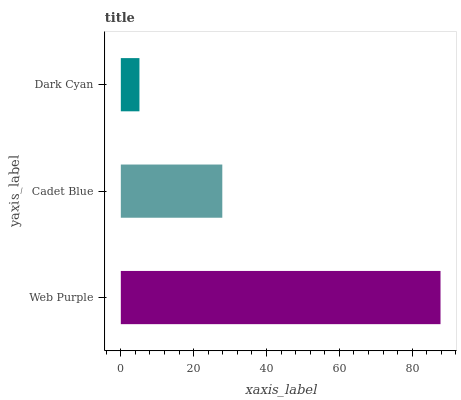Is Dark Cyan the minimum?
Answer yes or no. Yes. Is Web Purple the maximum?
Answer yes or no. Yes. Is Cadet Blue the minimum?
Answer yes or no. No. Is Cadet Blue the maximum?
Answer yes or no. No. Is Web Purple greater than Cadet Blue?
Answer yes or no. Yes. Is Cadet Blue less than Web Purple?
Answer yes or no. Yes. Is Cadet Blue greater than Web Purple?
Answer yes or no. No. Is Web Purple less than Cadet Blue?
Answer yes or no. No. Is Cadet Blue the high median?
Answer yes or no. Yes. Is Cadet Blue the low median?
Answer yes or no. Yes. Is Dark Cyan the high median?
Answer yes or no. No. Is Dark Cyan the low median?
Answer yes or no. No. 